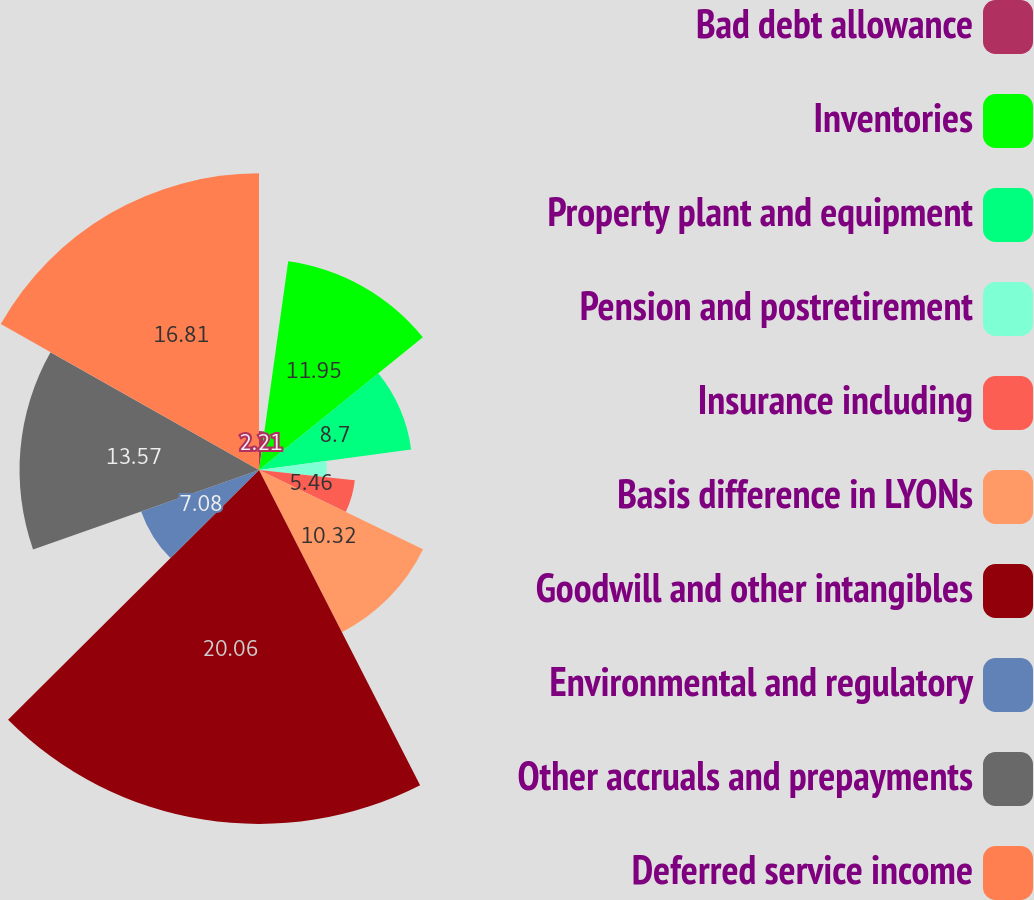<chart> <loc_0><loc_0><loc_500><loc_500><pie_chart><fcel>Bad debt allowance<fcel>Inventories<fcel>Property plant and equipment<fcel>Pension and postretirement<fcel>Insurance including<fcel>Basis difference in LYONs<fcel>Goodwill and other intangibles<fcel>Environmental and regulatory<fcel>Other accruals and prepayments<fcel>Deferred service income<nl><fcel>2.21%<fcel>11.95%<fcel>8.7%<fcel>3.84%<fcel>5.46%<fcel>10.32%<fcel>20.06%<fcel>7.08%<fcel>13.57%<fcel>16.81%<nl></chart> 